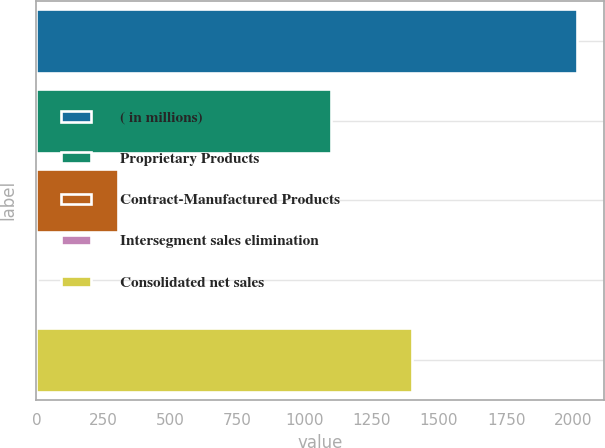Convert chart. <chart><loc_0><loc_0><loc_500><loc_500><bar_chart><fcel>( in millions)<fcel>Proprietary Products<fcel>Contract-Manufactured Products<fcel>Intersegment sales elimination<fcel>Consolidated net sales<nl><fcel>2015<fcel>1098.3<fcel>302.4<fcel>0.9<fcel>1399.8<nl></chart> 